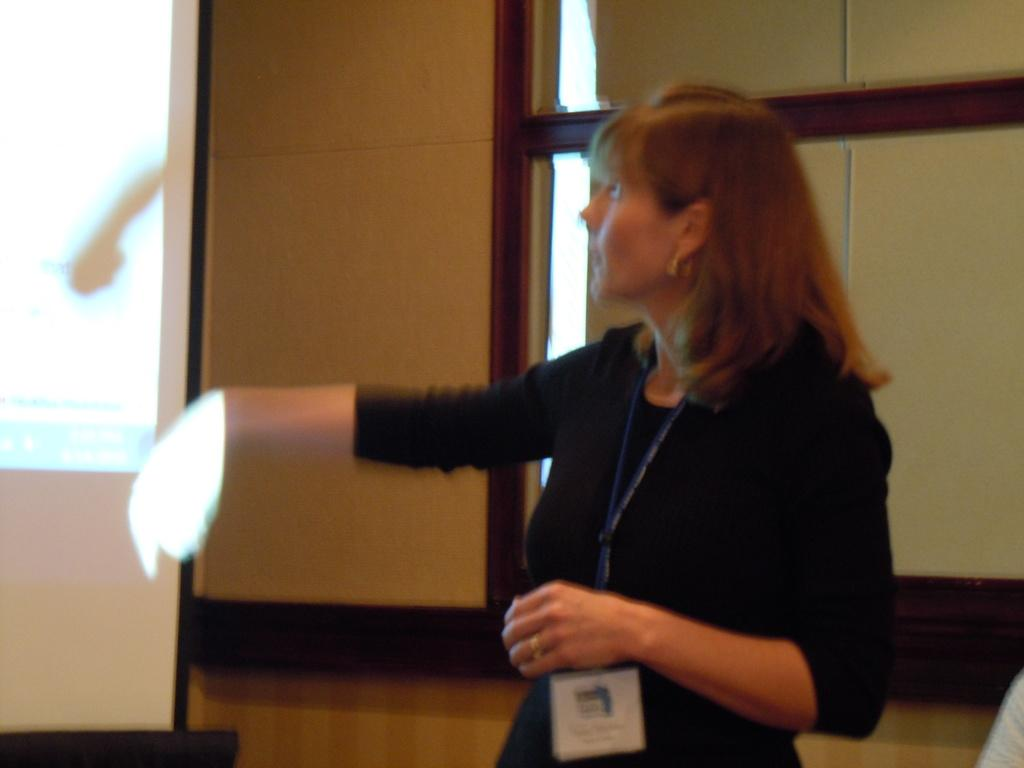Who is the main subject in the image? There is a lady standing in the center of the image. What is the lady wearing that can be identified in the image? The lady is wearing an ID card. What can be seen on the left side of the image? There is a projector screen on the left side of the image. What type of architectural feature is visible at the top of the image? There is a wall visible at the top of the image. What type of leather is used to make the lady's shoes in the image? There is no information about the lady's shoes in the image, so we cannot determine the type of leather used. 